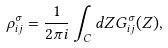<formula> <loc_0><loc_0><loc_500><loc_500>\rho _ { i j } ^ { \sigma } = \frac { 1 } { 2 \pi i } \int _ { C } d Z G _ { i j } ^ { \sigma } ( Z ) ,</formula> 